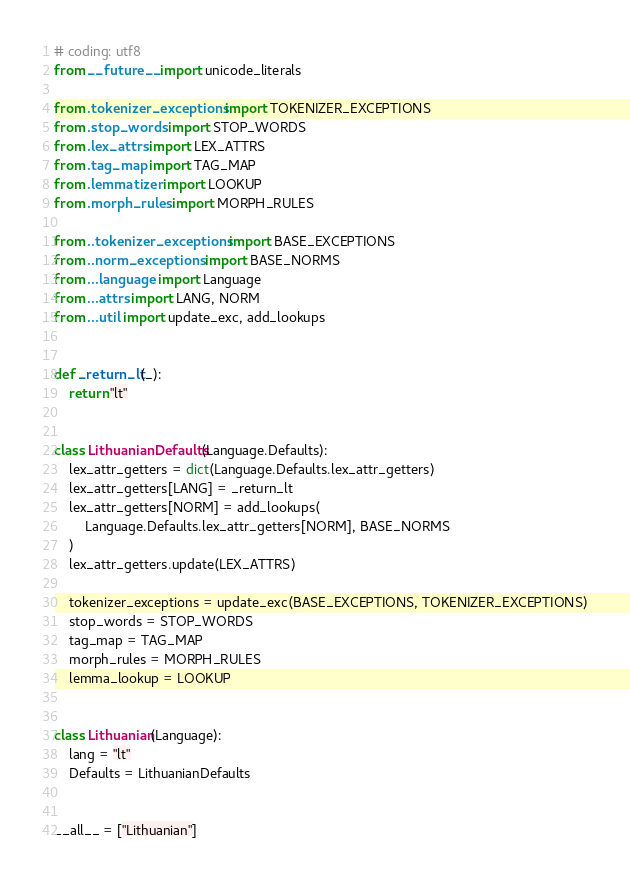<code> <loc_0><loc_0><loc_500><loc_500><_Python_># coding: utf8
from __future__ import unicode_literals

from .tokenizer_exceptions import TOKENIZER_EXCEPTIONS
from .stop_words import STOP_WORDS
from .lex_attrs import LEX_ATTRS
from .tag_map import TAG_MAP
from .lemmatizer import LOOKUP
from .morph_rules import MORPH_RULES

from ..tokenizer_exceptions import BASE_EXCEPTIONS
from ..norm_exceptions import BASE_NORMS
from ...language import Language
from ...attrs import LANG, NORM
from ...util import update_exc, add_lookups


def _return_lt(_):
    return "lt"


class LithuanianDefaults(Language.Defaults):
    lex_attr_getters = dict(Language.Defaults.lex_attr_getters)
    lex_attr_getters[LANG] = _return_lt
    lex_attr_getters[NORM] = add_lookups(
        Language.Defaults.lex_attr_getters[NORM], BASE_NORMS
    )
    lex_attr_getters.update(LEX_ATTRS)

    tokenizer_exceptions = update_exc(BASE_EXCEPTIONS, TOKENIZER_EXCEPTIONS)
    stop_words = STOP_WORDS
    tag_map = TAG_MAP
    morph_rules = MORPH_RULES
    lemma_lookup = LOOKUP


class Lithuanian(Language):
    lang = "lt"
    Defaults = LithuanianDefaults


__all__ = ["Lithuanian"]
</code> 